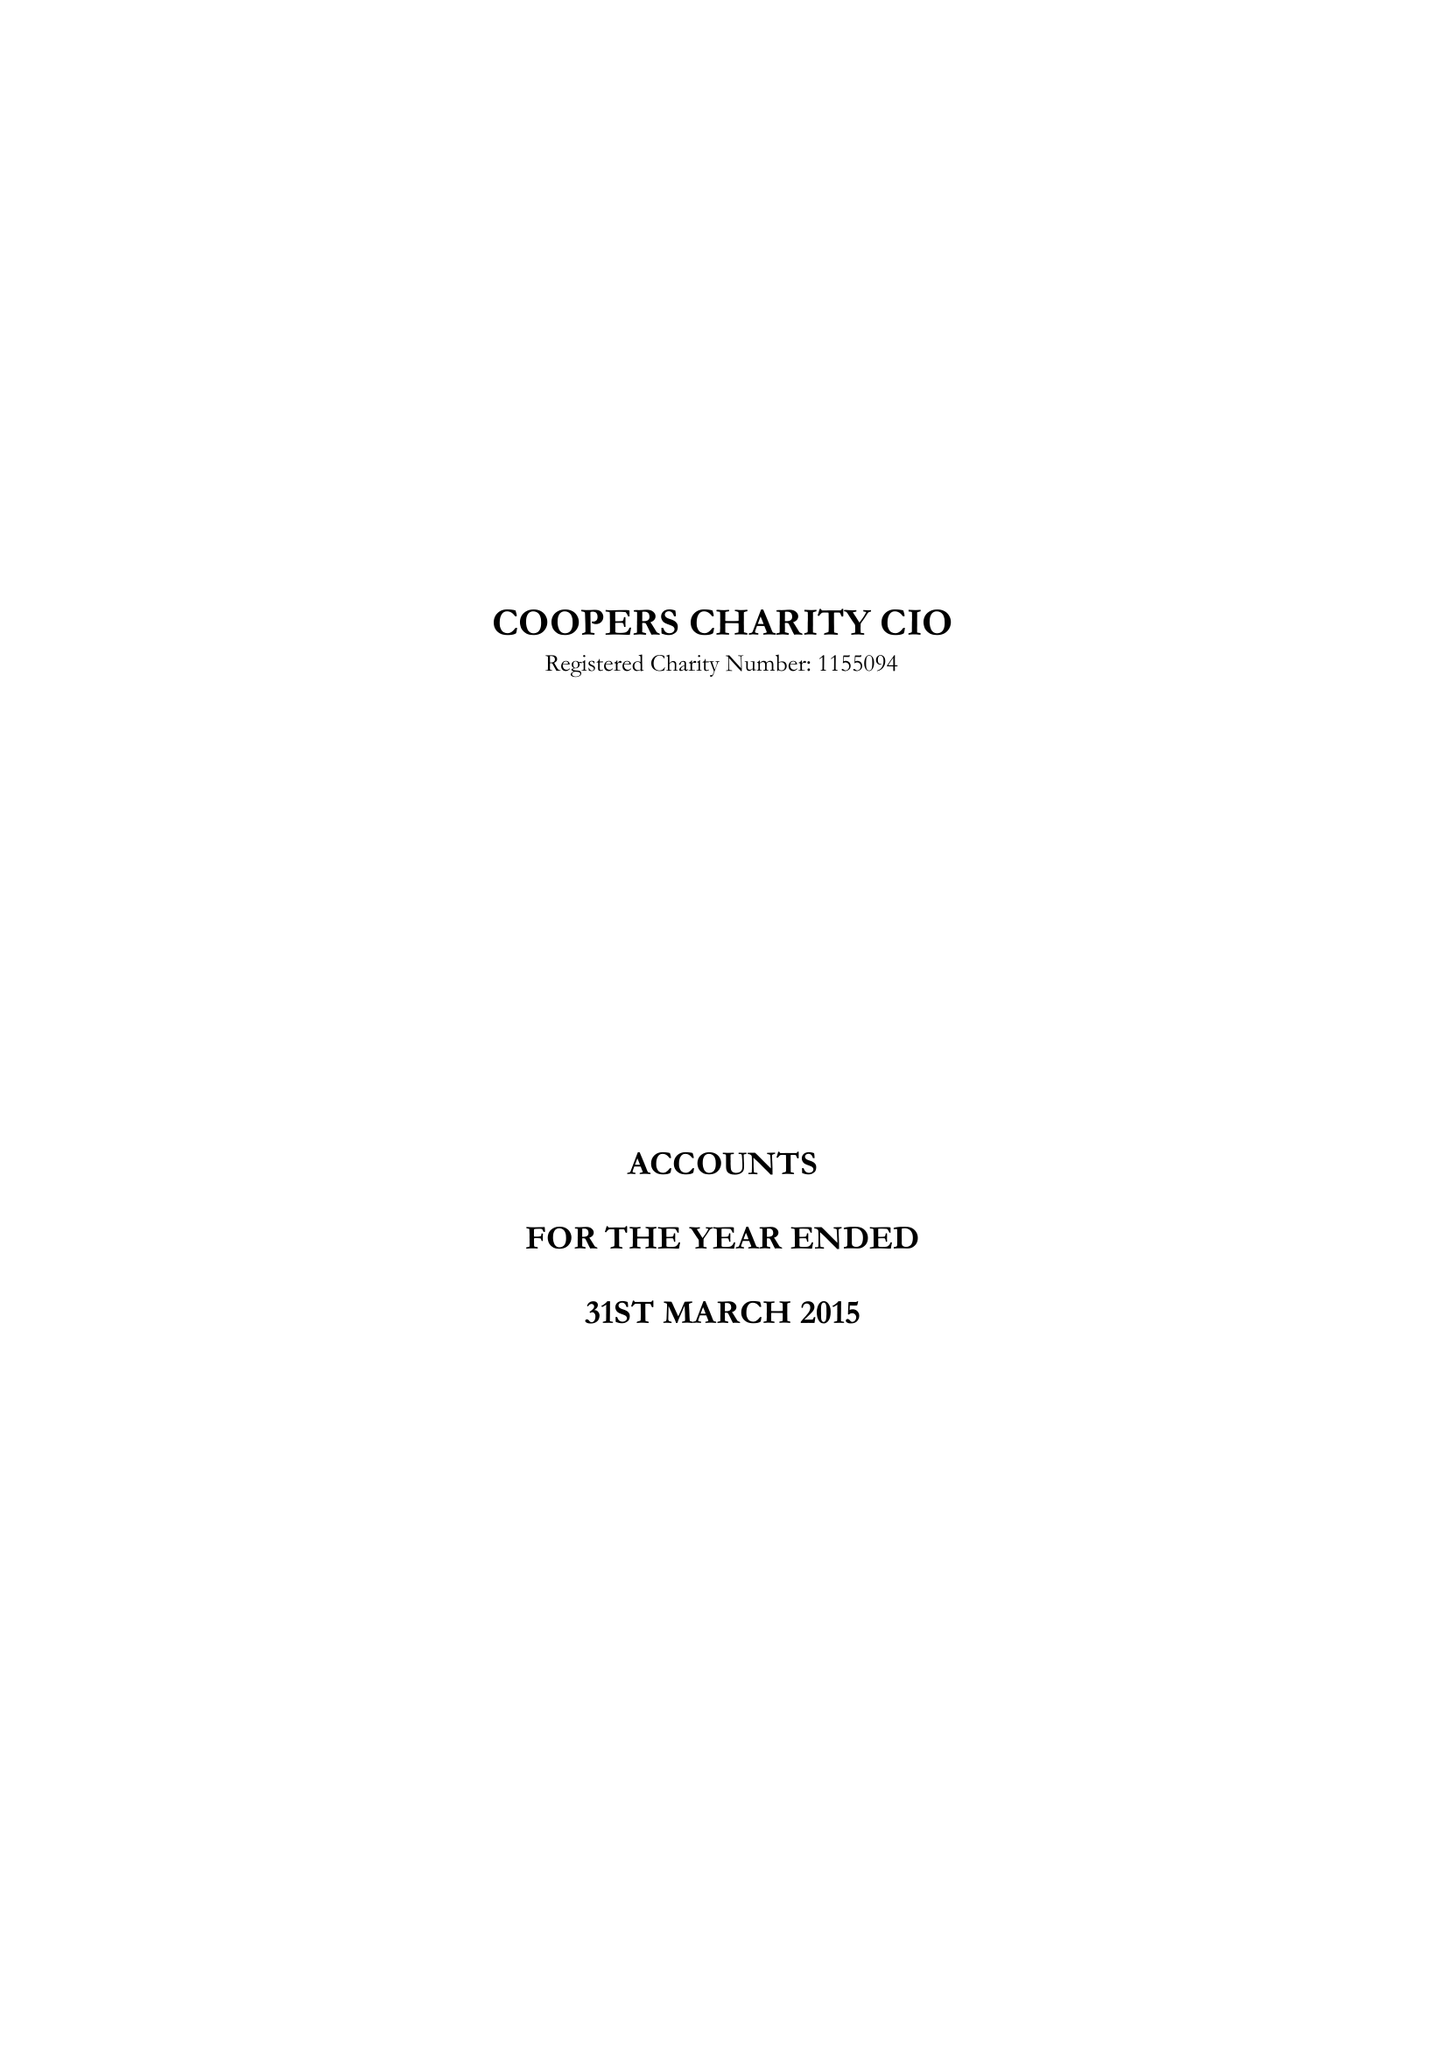What is the value for the address__street_line?
Answer the question using a single word or phrase. 13 DEVONSHIRE SQUARE 